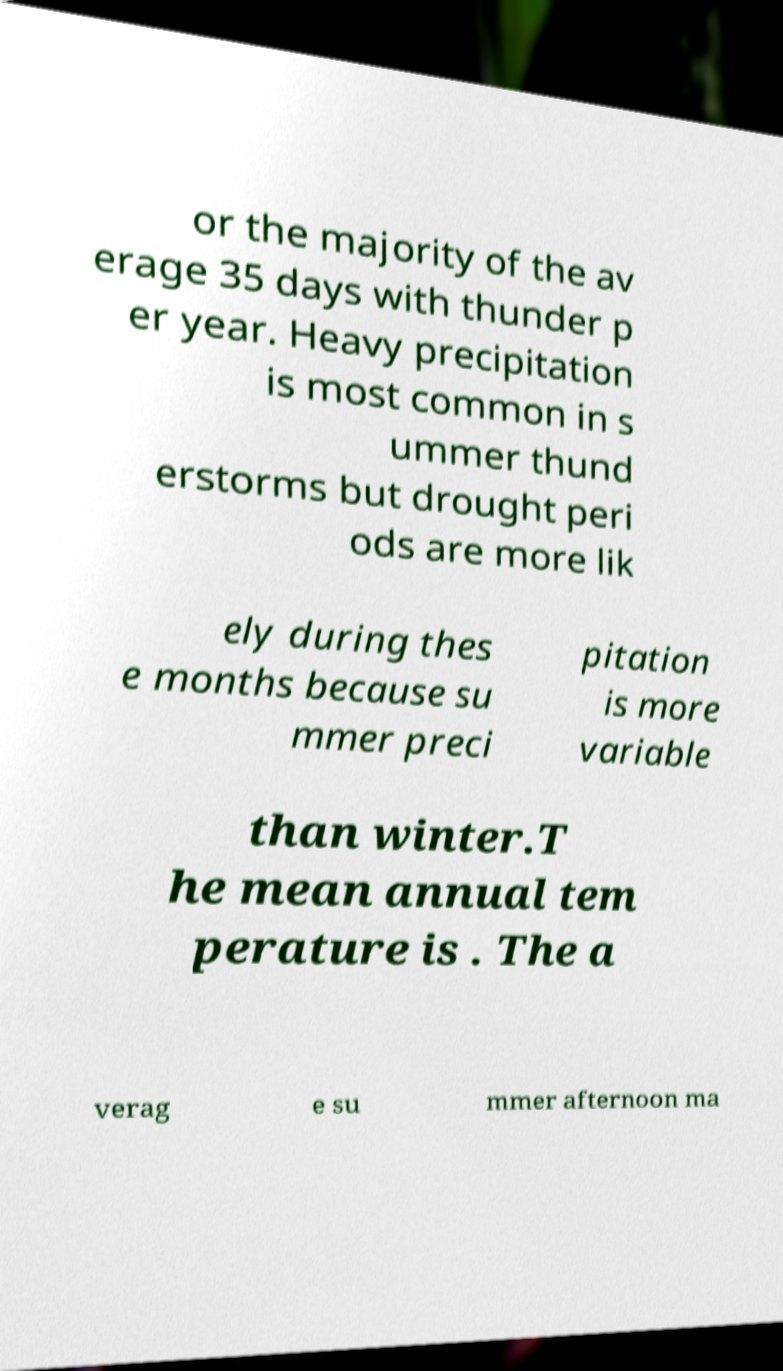Please read and relay the text visible in this image. What does it say? or the majority of the av erage 35 days with thunder p er year. Heavy precipitation is most common in s ummer thund erstorms but drought peri ods are more lik ely during thes e months because su mmer preci pitation is more variable than winter.T he mean annual tem perature is . The a verag e su mmer afternoon ma 